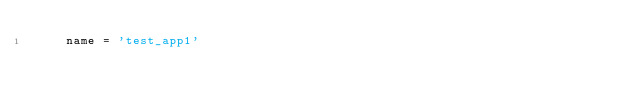<code> <loc_0><loc_0><loc_500><loc_500><_Python_>    name = 'test_app1'
</code> 